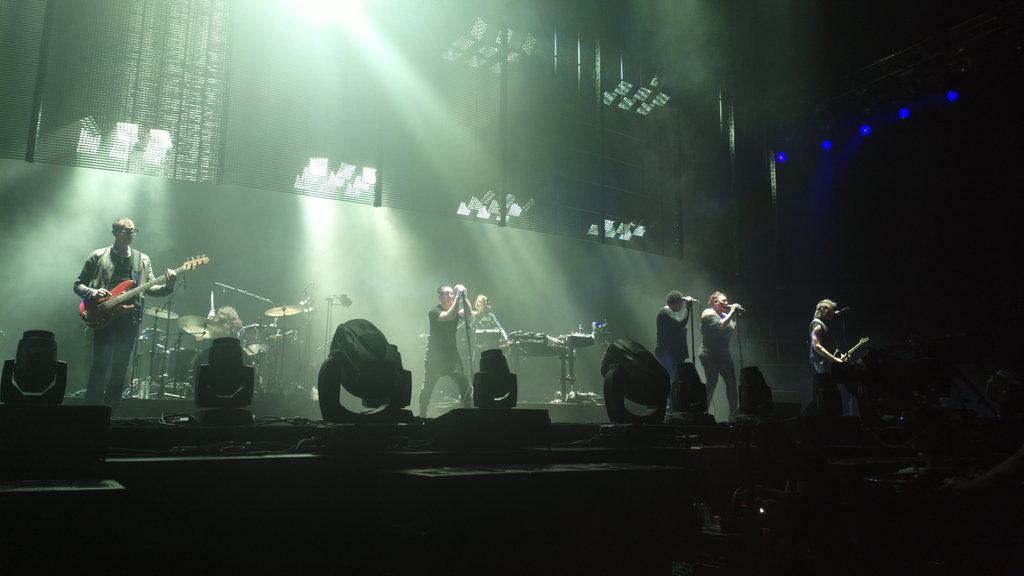What are the persons on the stage doing? The persons on the stage are singing in front of a microphone and playing musical instruments. What can be seen above the stage? There are focusing lights on top of the stage. What type of metal is being used as a prop in the crime scene depicted in the image? There is no crime scene or metal prop present in the image; it features persons on a stage singing and playing musical instruments. 